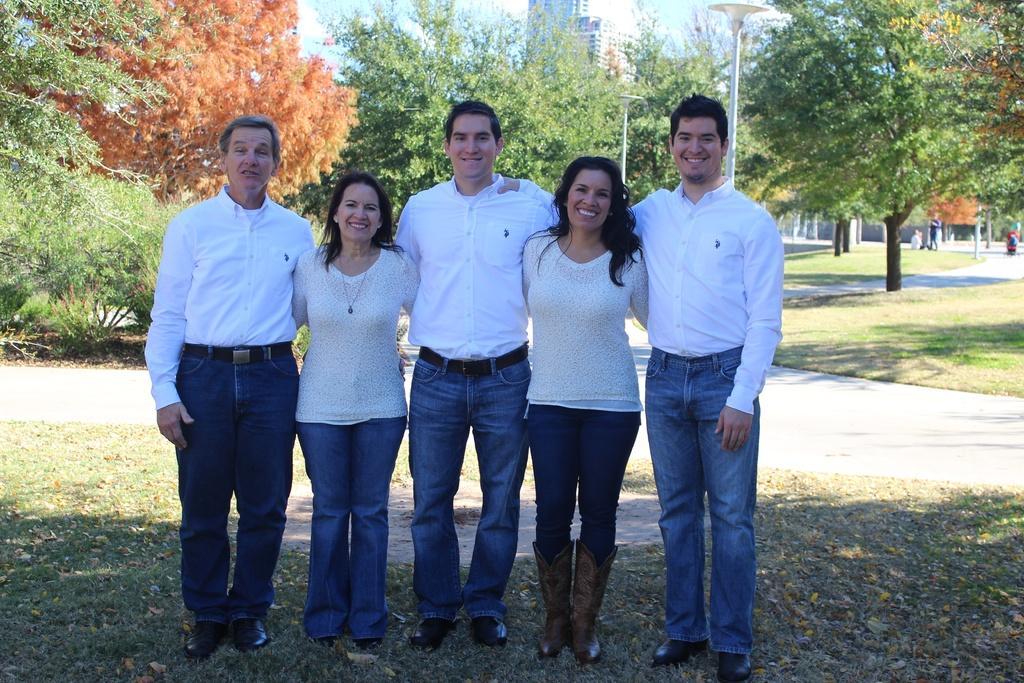Can you describe this image briefly? In this image I can see few people standing and wearing white top and jeans. Back Side I can see trees and poles. I can see building. The sky is in blue and white color. 